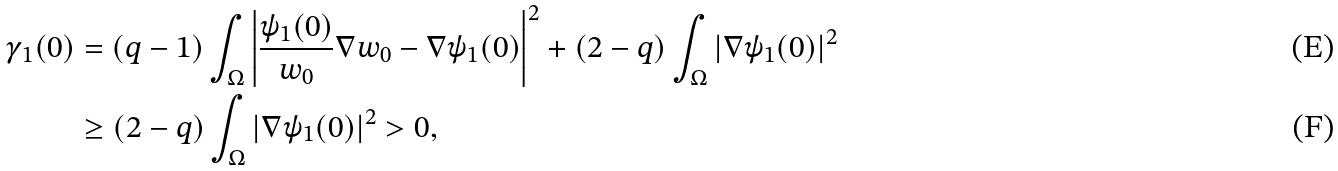Convert formula to latex. <formula><loc_0><loc_0><loc_500><loc_500>\gamma _ { 1 } ( 0 ) & = ( q - 1 ) \int _ { \Omega } \left | \frac { \psi _ { 1 } ( 0 ) } { w _ { 0 } } \nabla w _ { 0 } - \nabla \psi _ { 1 } ( 0 ) \right | ^ { 2 } + ( 2 - q ) \int _ { \Omega } | \nabla \psi _ { 1 } ( 0 ) | ^ { 2 } \\ & \geq ( 2 - q ) \int _ { \Omega } | \nabla \psi _ { 1 } ( 0 ) | ^ { 2 } > 0 ,</formula> 